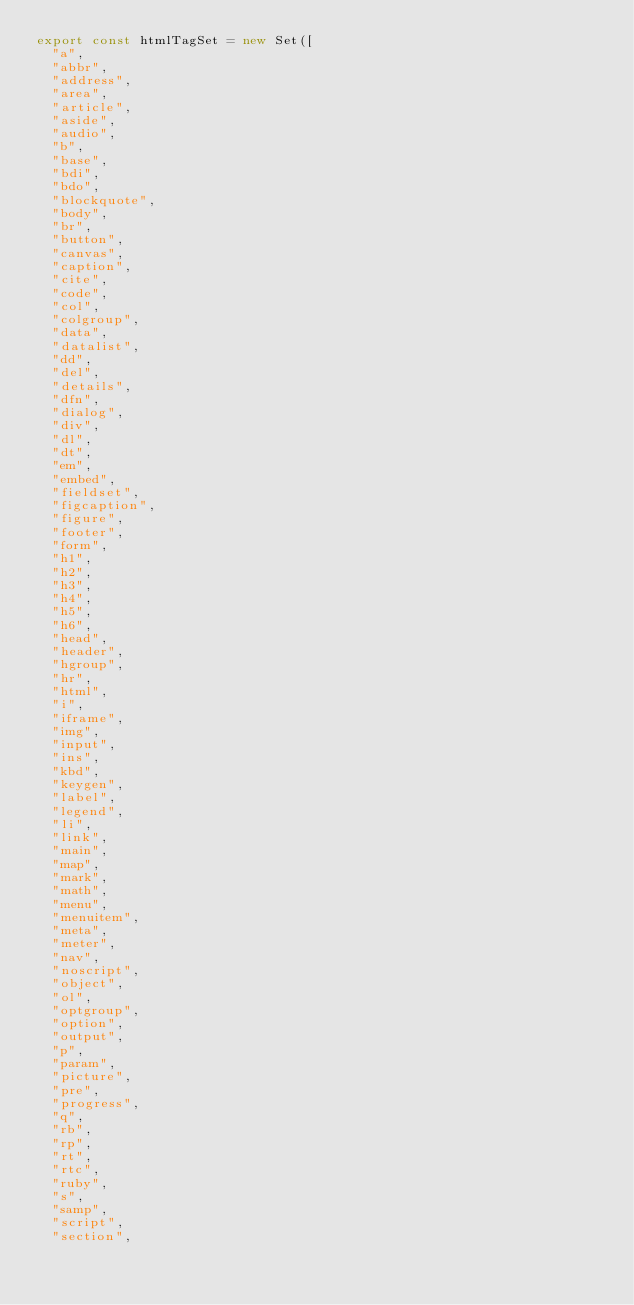<code> <loc_0><loc_0><loc_500><loc_500><_JavaScript_>export const htmlTagSet = new Set([
  "a",
  "abbr",
  "address",
  "area",
  "article",
  "aside",
  "audio",
  "b",
  "base",
  "bdi",
  "bdo",
  "blockquote",
  "body",
  "br",
  "button",
  "canvas",
  "caption",
  "cite",
  "code",
  "col",
  "colgroup",
  "data",
  "datalist",
  "dd",
  "del",
  "details",
  "dfn",
  "dialog",
  "div",
  "dl",
  "dt",
  "em",
  "embed",
  "fieldset",
  "figcaption",
  "figure",
  "footer",
  "form",
  "h1",
  "h2",
  "h3",
  "h4",
  "h5",
  "h6",
  "head",
  "header",
  "hgroup",
  "hr",
  "html",
  "i",
  "iframe",
  "img",
  "input",
  "ins",
  "kbd",
  "keygen",
  "label",
  "legend",
  "li",
  "link",
  "main",
  "map",
  "mark",
  "math",
  "menu",
  "menuitem",
  "meta",
  "meter",
  "nav",
  "noscript",
  "object",
  "ol",
  "optgroup",
  "option",
  "output",
  "p",
  "param",
  "picture",
  "pre",
  "progress",
  "q",
  "rb",
  "rp",
  "rt",
  "rtc",
  "ruby",
  "s",
  "samp",
  "script",
  "section",</code> 